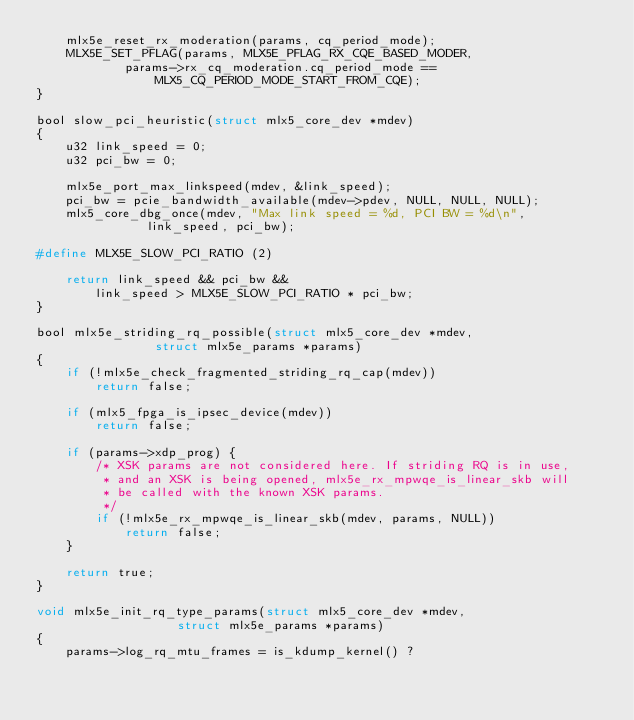Convert code to text. <code><loc_0><loc_0><loc_500><loc_500><_C_>	mlx5e_reset_rx_moderation(params, cq_period_mode);
	MLX5E_SET_PFLAG(params, MLX5E_PFLAG_RX_CQE_BASED_MODER,
			params->rx_cq_moderation.cq_period_mode ==
				MLX5_CQ_PERIOD_MODE_START_FROM_CQE);
}

bool slow_pci_heuristic(struct mlx5_core_dev *mdev)
{
	u32 link_speed = 0;
	u32 pci_bw = 0;

	mlx5e_port_max_linkspeed(mdev, &link_speed);
	pci_bw = pcie_bandwidth_available(mdev->pdev, NULL, NULL, NULL);
	mlx5_core_dbg_once(mdev, "Max link speed = %d, PCI BW = %d\n",
			   link_speed, pci_bw);

#define MLX5E_SLOW_PCI_RATIO (2)

	return link_speed && pci_bw &&
		link_speed > MLX5E_SLOW_PCI_RATIO * pci_bw;
}

bool mlx5e_striding_rq_possible(struct mlx5_core_dev *mdev,
				struct mlx5e_params *params)
{
	if (!mlx5e_check_fragmented_striding_rq_cap(mdev))
		return false;

	if (mlx5_fpga_is_ipsec_device(mdev))
		return false;

	if (params->xdp_prog) {
		/* XSK params are not considered here. If striding RQ is in use,
		 * and an XSK is being opened, mlx5e_rx_mpwqe_is_linear_skb will
		 * be called with the known XSK params.
		 */
		if (!mlx5e_rx_mpwqe_is_linear_skb(mdev, params, NULL))
			return false;
	}

	return true;
}

void mlx5e_init_rq_type_params(struct mlx5_core_dev *mdev,
			       struct mlx5e_params *params)
{
	params->log_rq_mtu_frames = is_kdump_kernel() ?</code> 